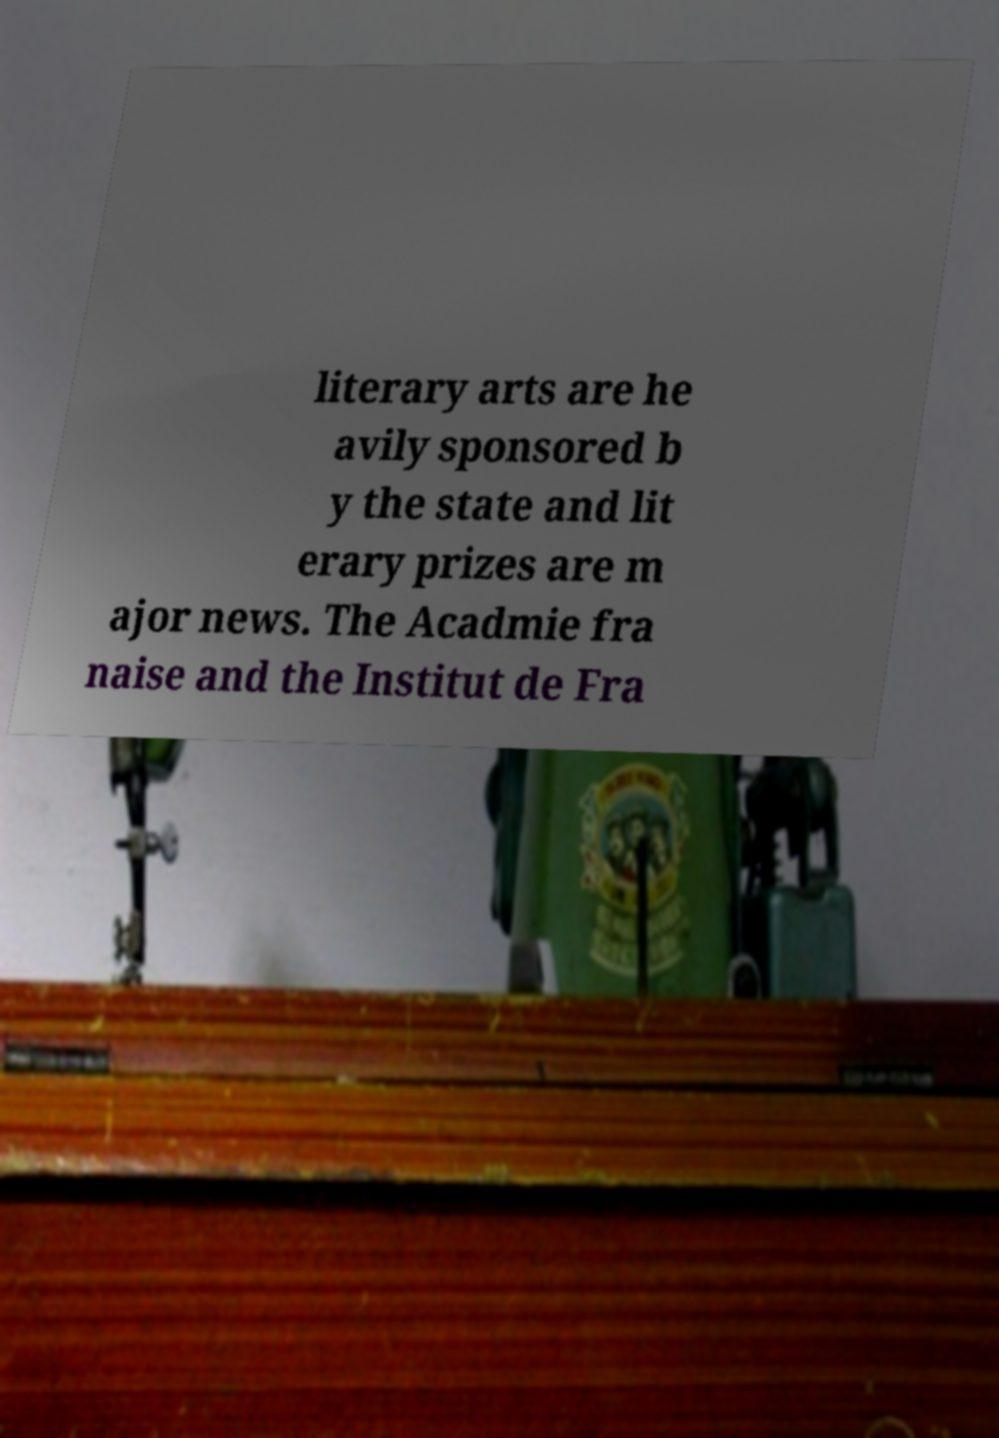What messages or text are displayed in this image? I need them in a readable, typed format. literary arts are he avily sponsored b y the state and lit erary prizes are m ajor news. The Acadmie fra naise and the Institut de Fra 